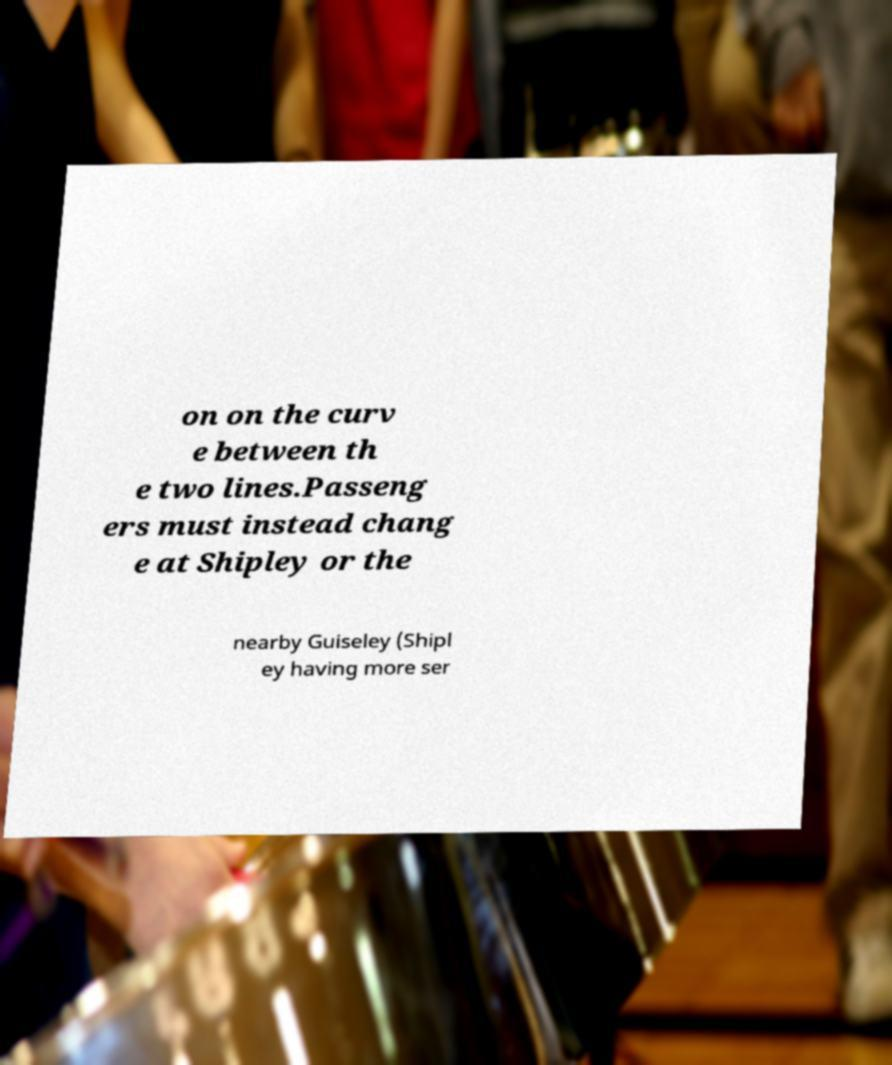Could you assist in decoding the text presented in this image and type it out clearly? on on the curv e between th e two lines.Passeng ers must instead chang e at Shipley or the nearby Guiseley (Shipl ey having more ser 